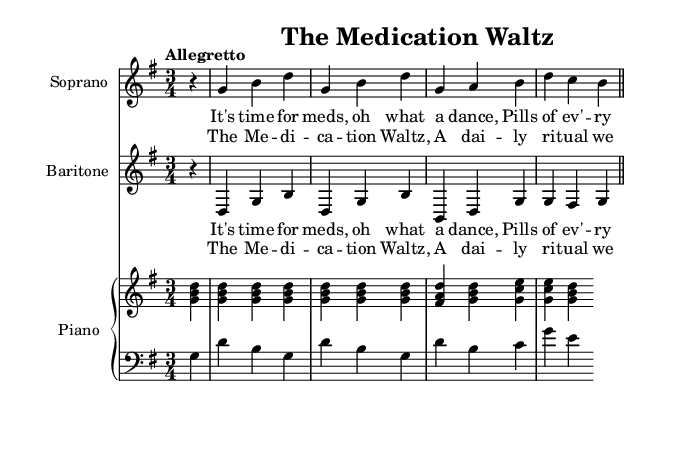What is the key signature of this music? The key signature is G major, which has one sharp (F#). We can determine this from the global section at the beginning where "\key g \major" is stated.
Answer: G major What is the time signature of this music? The time signature is 3/4, indicating three beats per measure. This can be found in the global section under "\time 3/4".
Answer: 3/4 What is the tempo marking indicated in the music? The tempo marking is "Allegretto", which is specified in the global section. This indicates a moderately fast speed.
Answer: Allegretto How many measures are in the soprano part? The soprano part has a total of two measures visible in the snippet. This can be determined by counting the vertical lines (bar lines) which separate each measure.
Answer: Two What is the main theme of the lyrics? The main theme revolves around the daily routine of medication in a care facility, highlighted by the lyrics which mention taking pills. This is emphasized in the first line of the verse.
Answer: Medication routine What type of musical work is this? This work is a comic opera, as indicated by the description of the scenes depicting everyday life in a care facility. The title "The Medication Waltz" and the light-hearted nature further suggest this classification.
Answer: Comic opera What is the accompaniment for the piano part? The piano part consists of a right hand (RH) and a left hand (LH) that together provide harmonic support and accompaniment for the vocal parts. This can be seen in the layout of the staffs labeled as "right" and "left".
Answer: Piano accompaniment 